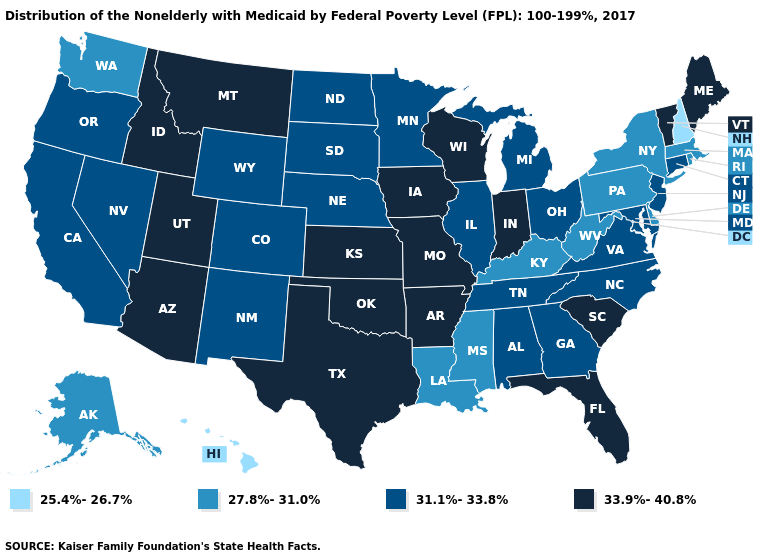What is the value of Wisconsin?
Keep it brief. 33.9%-40.8%. Which states have the lowest value in the USA?
Answer briefly. Hawaii, New Hampshire. Does South Dakota have the same value as Delaware?
Short answer required. No. What is the lowest value in the West?
Short answer required. 25.4%-26.7%. Does the map have missing data?
Short answer required. No. Name the states that have a value in the range 33.9%-40.8%?
Concise answer only. Arizona, Arkansas, Florida, Idaho, Indiana, Iowa, Kansas, Maine, Missouri, Montana, Oklahoma, South Carolina, Texas, Utah, Vermont, Wisconsin. Name the states that have a value in the range 33.9%-40.8%?
Concise answer only. Arizona, Arkansas, Florida, Idaho, Indiana, Iowa, Kansas, Maine, Missouri, Montana, Oklahoma, South Carolina, Texas, Utah, Vermont, Wisconsin. What is the value of Pennsylvania?
Be succinct. 27.8%-31.0%. What is the lowest value in the Northeast?
Short answer required. 25.4%-26.7%. What is the lowest value in the West?
Concise answer only. 25.4%-26.7%. Name the states that have a value in the range 33.9%-40.8%?
Keep it brief. Arizona, Arkansas, Florida, Idaho, Indiana, Iowa, Kansas, Maine, Missouri, Montana, Oklahoma, South Carolina, Texas, Utah, Vermont, Wisconsin. What is the value of California?
Answer briefly. 31.1%-33.8%. Does Kansas have the highest value in the USA?
Be succinct. Yes. Which states have the lowest value in the West?
Concise answer only. Hawaii. Does the map have missing data?
Answer briefly. No. 